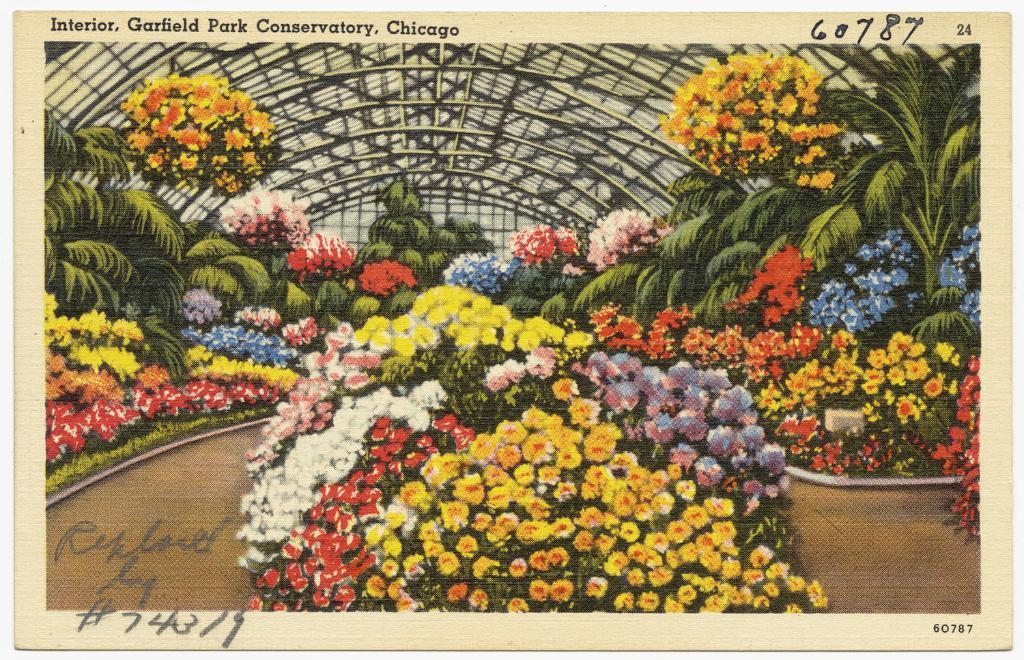What is depicted on the poster in the image? The poster contains flowers, plants, grass, and a shed. What other elements can be found on the poster? The poster also contains text and numbers. What type of power source is depicted in the image? There is no power source depicted in the image; the image only contains a poster with various elements. What type of stew is being prepared in the image? There is no stew being prepared in the image; the image only contains a poster with various elements. 